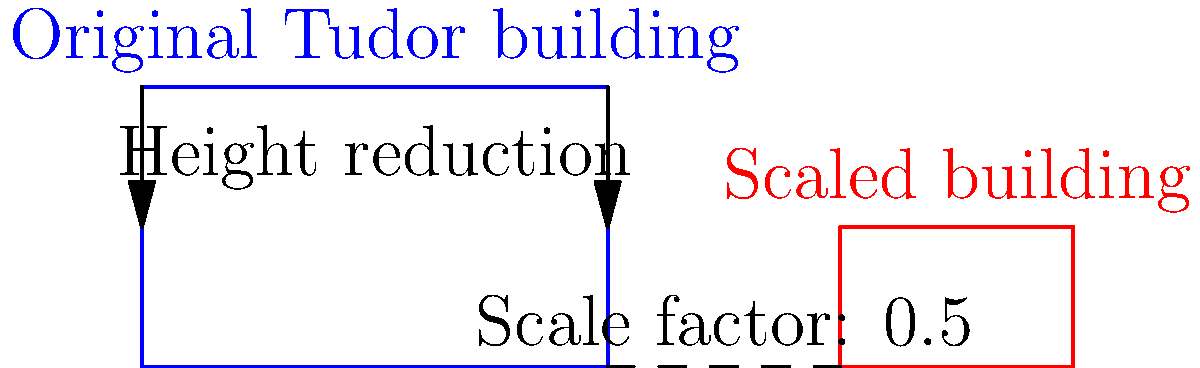A Tudor-era building from the 16th century has been studied for its architectural features. To explore changes in construction methods over time, you decide to create a scaled model of the building. If the original building's height is 12 meters and you apply a scale factor of 0.5 to all dimensions, what would be the volume of the scaled model as a fraction of the original building's volume? To solve this problem, let's follow these steps:

1. Understand the scaling:
   The scale factor of 0.5 means that all dimensions (length, width, and height) will be halved.

2. Consider the original dimensions:
   Let's say the original building has dimensions:
   Length (l) = x
   Width (w) = y
   Height (h) = 12 meters

3. Calculate the scaled dimensions:
   Scaled length = 0.5x
   Scaled width = 0.5y
   Scaled height = 0.5 * 12 = 6 meters

4. Compare volumes:
   Original volume = $V_1 = l * w * h = x * y * 12$
   Scaled volume = $V_2 = (0.5x) * (0.5y) * 6$

5. Express the scaled volume as a fraction of the original:
   $\frac{V_2}{V_1} = \frac{(0.5x) * (0.5y) * 6}{x * y * 12}$

6. Simplify:
   $\frac{V_2}{V_1} = \frac{0.25xy * 6}{xy * 12} = \frac{1.5xy}{12xy} = \frac{1}{8}$

Therefore, the volume of the scaled model is $\frac{1}{8}$ of the original building's volume.
Answer: $\frac{1}{8}$ 